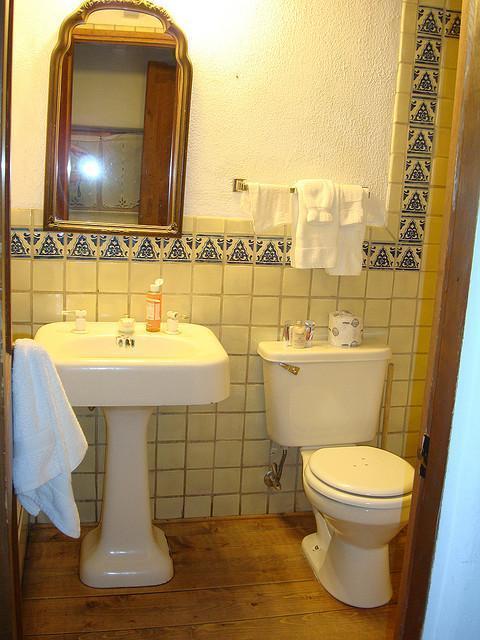How many sinks are there?
Give a very brief answer. 1. 